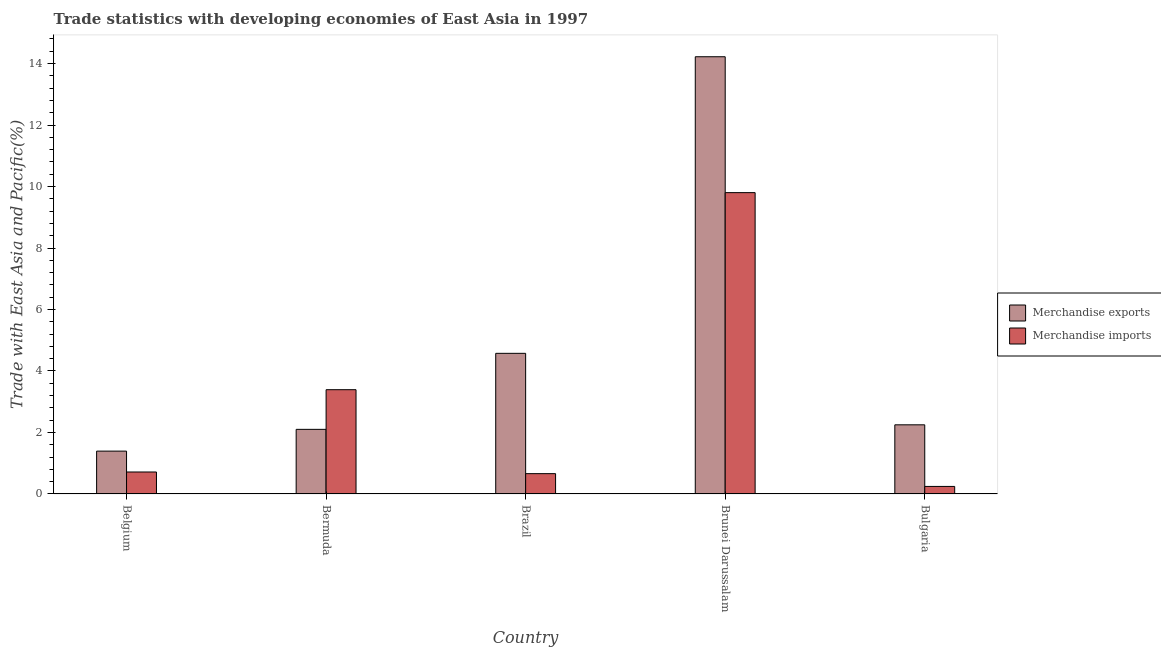Are the number of bars per tick equal to the number of legend labels?
Give a very brief answer. Yes. How many bars are there on the 3rd tick from the right?
Keep it short and to the point. 2. What is the label of the 1st group of bars from the left?
Your answer should be compact. Belgium. What is the merchandise exports in Brunei Darussalam?
Keep it short and to the point. 14.22. Across all countries, what is the maximum merchandise exports?
Provide a short and direct response. 14.22. Across all countries, what is the minimum merchandise imports?
Offer a terse response. 0.25. In which country was the merchandise imports maximum?
Your response must be concise. Brunei Darussalam. In which country was the merchandise imports minimum?
Your response must be concise. Bulgaria. What is the total merchandise imports in the graph?
Offer a terse response. 14.81. What is the difference between the merchandise exports in Belgium and that in Brazil?
Keep it short and to the point. -3.18. What is the difference between the merchandise imports in Brazil and the merchandise exports in Belgium?
Offer a terse response. -0.73. What is the average merchandise imports per country?
Ensure brevity in your answer.  2.96. What is the difference between the merchandise exports and merchandise imports in Bulgaria?
Your answer should be very brief. 2. In how many countries, is the merchandise imports greater than 7.2 %?
Your answer should be very brief. 1. What is the ratio of the merchandise imports in Bermuda to that in Brazil?
Your answer should be compact. 5.13. Is the difference between the merchandise imports in Brazil and Brunei Darussalam greater than the difference between the merchandise exports in Brazil and Brunei Darussalam?
Provide a succinct answer. Yes. What is the difference between the highest and the second highest merchandise exports?
Your answer should be very brief. 9.65. What is the difference between the highest and the lowest merchandise imports?
Provide a succinct answer. 9.56. In how many countries, is the merchandise exports greater than the average merchandise exports taken over all countries?
Your answer should be very brief. 1. Is the sum of the merchandise exports in Belgium and Brunei Darussalam greater than the maximum merchandise imports across all countries?
Offer a terse response. Yes. What does the 1st bar from the left in Brazil represents?
Offer a terse response. Merchandise exports. How many legend labels are there?
Offer a very short reply. 2. How are the legend labels stacked?
Keep it short and to the point. Vertical. What is the title of the graph?
Keep it short and to the point. Trade statistics with developing economies of East Asia in 1997. What is the label or title of the X-axis?
Your response must be concise. Country. What is the label or title of the Y-axis?
Offer a very short reply. Trade with East Asia and Pacific(%). What is the Trade with East Asia and Pacific(%) of Merchandise exports in Belgium?
Offer a very short reply. 1.39. What is the Trade with East Asia and Pacific(%) of Merchandise imports in Belgium?
Make the answer very short. 0.71. What is the Trade with East Asia and Pacific(%) of Merchandise exports in Bermuda?
Make the answer very short. 2.1. What is the Trade with East Asia and Pacific(%) in Merchandise imports in Bermuda?
Provide a succinct answer. 3.39. What is the Trade with East Asia and Pacific(%) in Merchandise exports in Brazil?
Offer a very short reply. 4.57. What is the Trade with East Asia and Pacific(%) of Merchandise imports in Brazil?
Provide a short and direct response. 0.66. What is the Trade with East Asia and Pacific(%) of Merchandise exports in Brunei Darussalam?
Keep it short and to the point. 14.22. What is the Trade with East Asia and Pacific(%) of Merchandise imports in Brunei Darussalam?
Provide a succinct answer. 9.8. What is the Trade with East Asia and Pacific(%) of Merchandise exports in Bulgaria?
Offer a very short reply. 2.25. What is the Trade with East Asia and Pacific(%) of Merchandise imports in Bulgaria?
Give a very brief answer. 0.25. Across all countries, what is the maximum Trade with East Asia and Pacific(%) of Merchandise exports?
Keep it short and to the point. 14.22. Across all countries, what is the maximum Trade with East Asia and Pacific(%) of Merchandise imports?
Provide a short and direct response. 9.8. Across all countries, what is the minimum Trade with East Asia and Pacific(%) of Merchandise exports?
Keep it short and to the point. 1.39. Across all countries, what is the minimum Trade with East Asia and Pacific(%) of Merchandise imports?
Provide a short and direct response. 0.25. What is the total Trade with East Asia and Pacific(%) in Merchandise exports in the graph?
Offer a very short reply. 24.54. What is the total Trade with East Asia and Pacific(%) of Merchandise imports in the graph?
Offer a very short reply. 14.81. What is the difference between the Trade with East Asia and Pacific(%) of Merchandise exports in Belgium and that in Bermuda?
Make the answer very short. -0.71. What is the difference between the Trade with East Asia and Pacific(%) in Merchandise imports in Belgium and that in Bermuda?
Offer a very short reply. -2.68. What is the difference between the Trade with East Asia and Pacific(%) of Merchandise exports in Belgium and that in Brazil?
Give a very brief answer. -3.18. What is the difference between the Trade with East Asia and Pacific(%) of Merchandise imports in Belgium and that in Brazil?
Offer a very short reply. 0.05. What is the difference between the Trade with East Asia and Pacific(%) in Merchandise exports in Belgium and that in Brunei Darussalam?
Provide a short and direct response. -12.83. What is the difference between the Trade with East Asia and Pacific(%) of Merchandise imports in Belgium and that in Brunei Darussalam?
Provide a short and direct response. -9.09. What is the difference between the Trade with East Asia and Pacific(%) of Merchandise exports in Belgium and that in Bulgaria?
Offer a very short reply. -0.86. What is the difference between the Trade with East Asia and Pacific(%) in Merchandise imports in Belgium and that in Bulgaria?
Give a very brief answer. 0.47. What is the difference between the Trade with East Asia and Pacific(%) of Merchandise exports in Bermuda and that in Brazil?
Make the answer very short. -2.47. What is the difference between the Trade with East Asia and Pacific(%) in Merchandise imports in Bermuda and that in Brazil?
Offer a terse response. 2.73. What is the difference between the Trade with East Asia and Pacific(%) of Merchandise exports in Bermuda and that in Brunei Darussalam?
Your response must be concise. -12.12. What is the difference between the Trade with East Asia and Pacific(%) of Merchandise imports in Bermuda and that in Brunei Darussalam?
Give a very brief answer. -6.41. What is the difference between the Trade with East Asia and Pacific(%) of Merchandise exports in Bermuda and that in Bulgaria?
Keep it short and to the point. -0.15. What is the difference between the Trade with East Asia and Pacific(%) in Merchandise imports in Bermuda and that in Bulgaria?
Keep it short and to the point. 3.15. What is the difference between the Trade with East Asia and Pacific(%) in Merchandise exports in Brazil and that in Brunei Darussalam?
Your answer should be compact. -9.65. What is the difference between the Trade with East Asia and Pacific(%) in Merchandise imports in Brazil and that in Brunei Darussalam?
Your response must be concise. -9.14. What is the difference between the Trade with East Asia and Pacific(%) of Merchandise exports in Brazil and that in Bulgaria?
Give a very brief answer. 2.33. What is the difference between the Trade with East Asia and Pacific(%) of Merchandise imports in Brazil and that in Bulgaria?
Your answer should be compact. 0.42. What is the difference between the Trade with East Asia and Pacific(%) in Merchandise exports in Brunei Darussalam and that in Bulgaria?
Give a very brief answer. 11.97. What is the difference between the Trade with East Asia and Pacific(%) in Merchandise imports in Brunei Darussalam and that in Bulgaria?
Provide a succinct answer. 9.56. What is the difference between the Trade with East Asia and Pacific(%) in Merchandise exports in Belgium and the Trade with East Asia and Pacific(%) in Merchandise imports in Bermuda?
Ensure brevity in your answer.  -2. What is the difference between the Trade with East Asia and Pacific(%) in Merchandise exports in Belgium and the Trade with East Asia and Pacific(%) in Merchandise imports in Brazil?
Keep it short and to the point. 0.73. What is the difference between the Trade with East Asia and Pacific(%) in Merchandise exports in Belgium and the Trade with East Asia and Pacific(%) in Merchandise imports in Brunei Darussalam?
Your response must be concise. -8.41. What is the difference between the Trade with East Asia and Pacific(%) in Merchandise exports in Belgium and the Trade with East Asia and Pacific(%) in Merchandise imports in Bulgaria?
Your response must be concise. 1.15. What is the difference between the Trade with East Asia and Pacific(%) in Merchandise exports in Bermuda and the Trade with East Asia and Pacific(%) in Merchandise imports in Brazil?
Provide a short and direct response. 1.44. What is the difference between the Trade with East Asia and Pacific(%) in Merchandise exports in Bermuda and the Trade with East Asia and Pacific(%) in Merchandise imports in Brunei Darussalam?
Give a very brief answer. -7.7. What is the difference between the Trade with East Asia and Pacific(%) in Merchandise exports in Bermuda and the Trade with East Asia and Pacific(%) in Merchandise imports in Bulgaria?
Ensure brevity in your answer.  1.86. What is the difference between the Trade with East Asia and Pacific(%) in Merchandise exports in Brazil and the Trade with East Asia and Pacific(%) in Merchandise imports in Brunei Darussalam?
Your answer should be very brief. -5.23. What is the difference between the Trade with East Asia and Pacific(%) of Merchandise exports in Brazil and the Trade with East Asia and Pacific(%) of Merchandise imports in Bulgaria?
Provide a succinct answer. 4.33. What is the difference between the Trade with East Asia and Pacific(%) of Merchandise exports in Brunei Darussalam and the Trade with East Asia and Pacific(%) of Merchandise imports in Bulgaria?
Provide a succinct answer. 13.98. What is the average Trade with East Asia and Pacific(%) in Merchandise exports per country?
Offer a very short reply. 4.91. What is the average Trade with East Asia and Pacific(%) in Merchandise imports per country?
Provide a short and direct response. 2.96. What is the difference between the Trade with East Asia and Pacific(%) of Merchandise exports and Trade with East Asia and Pacific(%) of Merchandise imports in Belgium?
Provide a succinct answer. 0.68. What is the difference between the Trade with East Asia and Pacific(%) of Merchandise exports and Trade with East Asia and Pacific(%) of Merchandise imports in Bermuda?
Keep it short and to the point. -1.29. What is the difference between the Trade with East Asia and Pacific(%) in Merchandise exports and Trade with East Asia and Pacific(%) in Merchandise imports in Brazil?
Make the answer very short. 3.91. What is the difference between the Trade with East Asia and Pacific(%) of Merchandise exports and Trade with East Asia and Pacific(%) of Merchandise imports in Brunei Darussalam?
Your response must be concise. 4.42. What is the difference between the Trade with East Asia and Pacific(%) in Merchandise exports and Trade with East Asia and Pacific(%) in Merchandise imports in Bulgaria?
Make the answer very short. 2. What is the ratio of the Trade with East Asia and Pacific(%) in Merchandise exports in Belgium to that in Bermuda?
Provide a succinct answer. 0.66. What is the ratio of the Trade with East Asia and Pacific(%) in Merchandise imports in Belgium to that in Bermuda?
Offer a terse response. 0.21. What is the ratio of the Trade with East Asia and Pacific(%) of Merchandise exports in Belgium to that in Brazil?
Provide a succinct answer. 0.3. What is the ratio of the Trade with East Asia and Pacific(%) in Merchandise imports in Belgium to that in Brazil?
Your response must be concise. 1.08. What is the ratio of the Trade with East Asia and Pacific(%) of Merchandise exports in Belgium to that in Brunei Darussalam?
Keep it short and to the point. 0.1. What is the ratio of the Trade with East Asia and Pacific(%) of Merchandise imports in Belgium to that in Brunei Darussalam?
Your response must be concise. 0.07. What is the ratio of the Trade with East Asia and Pacific(%) in Merchandise exports in Belgium to that in Bulgaria?
Your answer should be compact. 0.62. What is the ratio of the Trade with East Asia and Pacific(%) of Merchandise imports in Belgium to that in Bulgaria?
Provide a short and direct response. 2.91. What is the ratio of the Trade with East Asia and Pacific(%) of Merchandise exports in Bermuda to that in Brazil?
Give a very brief answer. 0.46. What is the ratio of the Trade with East Asia and Pacific(%) in Merchandise imports in Bermuda to that in Brazil?
Offer a terse response. 5.13. What is the ratio of the Trade with East Asia and Pacific(%) of Merchandise exports in Bermuda to that in Brunei Darussalam?
Give a very brief answer. 0.15. What is the ratio of the Trade with East Asia and Pacific(%) in Merchandise imports in Bermuda to that in Brunei Darussalam?
Provide a succinct answer. 0.35. What is the ratio of the Trade with East Asia and Pacific(%) in Merchandise exports in Bermuda to that in Bulgaria?
Offer a terse response. 0.93. What is the ratio of the Trade with East Asia and Pacific(%) of Merchandise imports in Bermuda to that in Bulgaria?
Give a very brief answer. 13.83. What is the ratio of the Trade with East Asia and Pacific(%) of Merchandise exports in Brazil to that in Brunei Darussalam?
Give a very brief answer. 0.32. What is the ratio of the Trade with East Asia and Pacific(%) in Merchandise imports in Brazil to that in Brunei Darussalam?
Your response must be concise. 0.07. What is the ratio of the Trade with East Asia and Pacific(%) of Merchandise exports in Brazil to that in Bulgaria?
Your response must be concise. 2.03. What is the ratio of the Trade with East Asia and Pacific(%) of Merchandise imports in Brazil to that in Bulgaria?
Provide a succinct answer. 2.69. What is the ratio of the Trade with East Asia and Pacific(%) of Merchandise exports in Brunei Darussalam to that in Bulgaria?
Your response must be concise. 6.32. What is the ratio of the Trade with East Asia and Pacific(%) in Merchandise imports in Brunei Darussalam to that in Bulgaria?
Provide a succinct answer. 39.96. What is the difference between the highest and the second highest Trade with East Asia and Pacific(%) in Merchandise exports?
Your answer should be very brief. 9.65. What is the difference between the highest and the second highest Trade with East Asia and Pacific(%) in Merchandise imports?
Offer a terse response. 6.41. What is the difference between the highest and the lowest Trade with East Asia and Pacific(%) of Merchandise exports?
Your answer should be compact. 12.83. What is the difference between the highest and the lowest Trade with East Asia and Pacific(%) of Merchandise imports?
Your response must be concise. 9.56. 